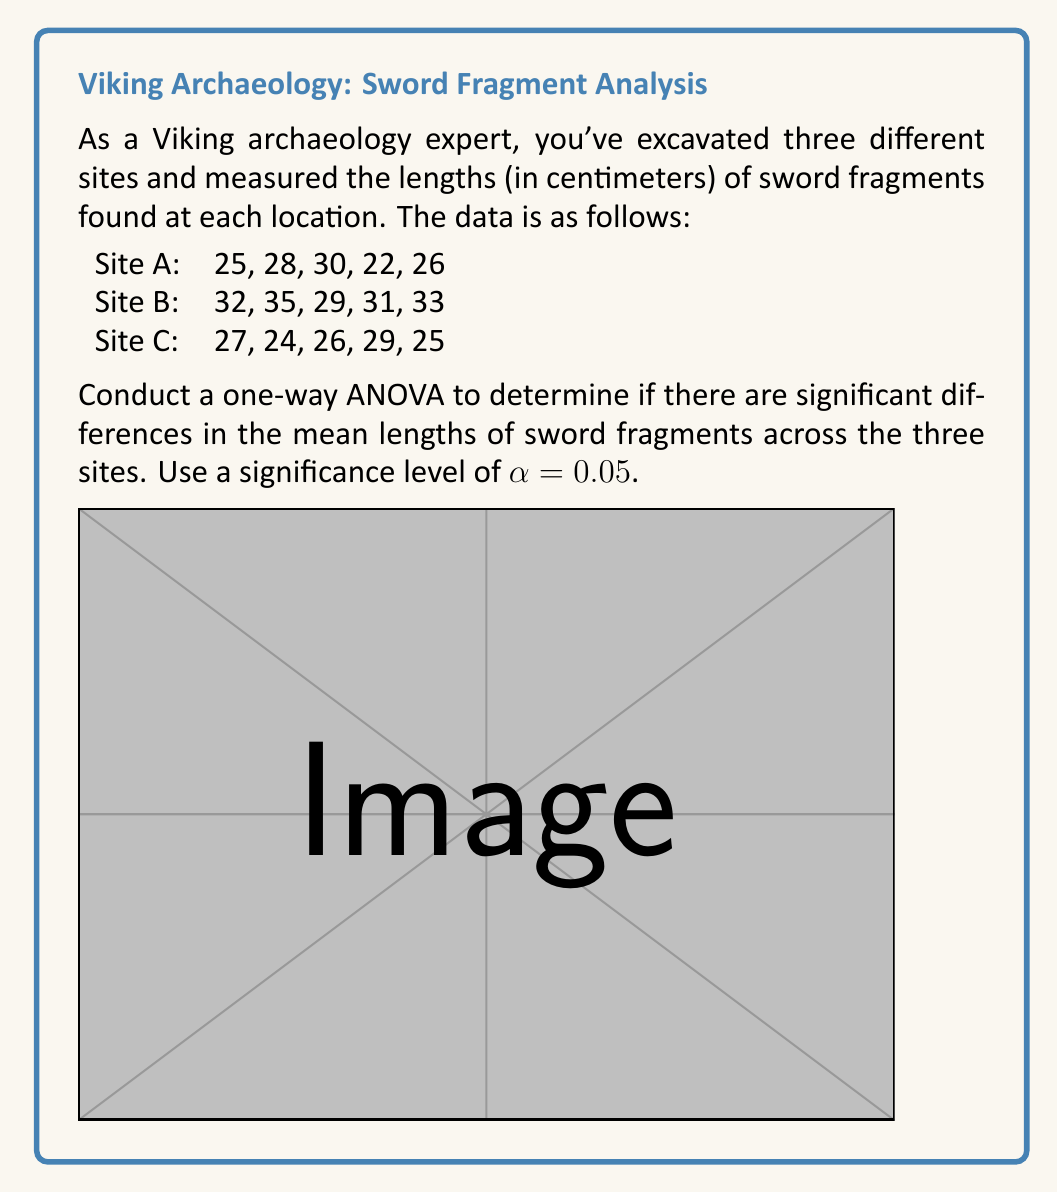Solve this math problem. Let's approach this step-by-step:

1) First, we need to calculate the following:
   - Grand mean
   - Sum of Squares Total (SST)
   - Sum of Squares Between (SSB)
   - Sum of Squares Within (SSW)

2) Calculate the grand mean:
   $\bar{X} = \frac{(25+28+30+22+26+32+35+29+31+33+27+24+26+29+25)}{15} = 28.13$

3) Calculate SST:
   $$SST = \sum_{i=1}^{3}\sum_{j=1}^{5}(X_{ij} - \bar{X})^2 = 246.94$$

4) Calculate SSB:
   $$SSB = 5[(28.2 - 28.13)^2 + (32 - 28.13)^2 + (26.2 - 28.13)^2] = 108.13$$

5) Calculate SSW:
   $$SSW = SST - SSB = 246.94 - 108.13 = 138.81$$

6) Calculate degrees of freedom:
   - Between groups: $df_B = 3 - 1 = 2$
   - Within groups: $df_W = 15 - 3 = 12$
   - Total: $df_T = 15 - 1 = 14$

7) Calculate Mean Squares:
   $$MS_B = \frac{SSB}{df_B} = \frac{108.13}{2} = 54.065$$
   $$MS_W = \frac{SSW}{df_W} = \frac{138.81}{12} = 11.5675$$

8) Calculate F-statistic:
   $$F = \frac{MS_B}{MS_W} = \frac{54.065}{11.5675} = 4.67$$

9) Find the critical F-value:
   For $\alpha = 0.05$, $df_B = 2$, and $df_W = 12$, the critical F-value is approximately 3.89.

10) Compare F-statistic to critical F-value:
    Since 4.67 > 3.89, we reject the null hypothesis.
Answer: F(2,12) = 4.67, p < 0.05. Significant differences exist in mean sword fragment lengths across sites. 